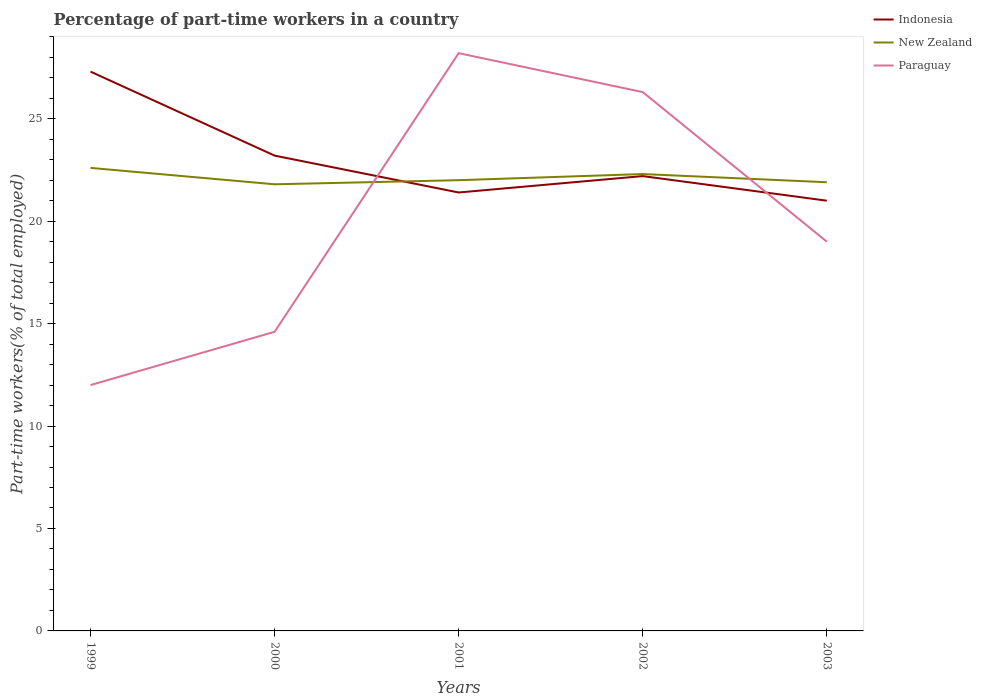How many different coloured lines are there?
Your response must be concise. 3. Does the line corresponding to Indonesia intersect with the line corresponding to New Zealand?
Your answer should be very brief. Yes. Is the number of lines equal to the number of legend labels?
Offer a terse response. Yes. In which year was the percentage of part-time workers in New Zealand maximum?
Your response must be concise. 2000. What is the difference between the highest and the second highest percentage of part-time workers in Indonesia?
Keep it short and to the point. 6.3. Is the percentage of part-time workers in Indonesia strictly greater than the percentage of part-time workers in Paraguay over the years?
Provide a succinct answer. No. Are the values on the major ticks of Y-axis written in scientific E-notation?
Offer a terse response. No. Does the graph contain any zero values?
Keep it short and to the point. No. Where does the legend appear in the graph?
Keep it short and to the point. Top right. How many legend labels are there?
Your response must be concise. 3. What is the title of the graph?
Your answer should be very brief. Percentage of part-time workers in a country. What is the label or title of the X-axis?
Offer a terse response. Years. What is the label or title of the Y-axis?
Ensure brevity in your answer.  Part-time workers(% of total employed). What is the Part-time workers(% of total employed) in Indonesia in 1999?
Offer a terse response. 27.3. What is the Part-time workers(% of total employed) of New Zealand in 1999?
Your answer should be very brief. 22.6. What is the Part-time workers(% of total employed) in Paraguay in 1999?
Keep it short and to the point. 12. What is the Part-time workers(% of total employed) of Indonesia in 2000?
Your answer should be very brief. 23.2. What is the Part-time workers(% of total employed) of New Zealand in 2000?
Offer a very short reply. 21.8. What is the Part-time workers(% of total employed) in Paraguay in 2000?
Your response must be concise. 14.6. What is the Part-time workers(% of total employed) in Indonesia in 2001?
Provide a succinct answer. 21.4. What is the Part-time workers(% of total employed) of New Zealand in 2001?
Your answer should be compact. 22. What is the Part-time workers(% of total employed) in Paraguay in 2001?
Offer a very short reply. 28.2. What is the Part-time workers(% of total employed) of Indonesia in 2002?
Provide a short and direct response. 22.2. What is the Part-time workers(% of total employed) of New Zealand in 2002?
Give a very brief answer. 22.3. What is the Part-time workers(% of total employed) in Paraguay in 2002?
Provide a succinct answer. 26.3. What is the Part-time workers(% of total employed) of Indonesia in 2003?
Offer a very short reply. 21. What is the Part-time workers(% of total employed) in New Zealand in 2003?
Your answer should be very brief. 21.9. Across all years, what is the maximum Part-time workers(% of total employed) of Indonesia?
Offer a very short reply. 27.3. Across all years, what is the maximum Part-time workers(% of total employed) of New Zealand?
Provide a succinct answer. 22.6. Across all years, what is the maximum Part-time workers(% of total employed) in Paraguay?
Your answer should be very brief. 28.2. Across all years, what is the minimum Part-time workers(% of total employed) of New Zealand?
Offer a very short reply. 21.8. What is the total Part-time workers(% of total employed) in Indonesia in the graph?
Keep it short and to the point. 115.1. What is the total Part-time workers(% of total employed) in New Zealand in the graph?
Offer a terse response. 110.6. What is the total Part-time workers(% of total employed) of Paraguay in the graph?
Your response must be concise. 100.1. What is the difference between the Part-time workers(% of total employed) of New Zealand in 1999 and that in 2000?
Keep it short and to the point. 0.8. What is the difference between the Part-time workers(% of total employed) of Indonesia in 1999 and that in 2001?
Your answer should be very brief. 5.9. What is the difference between the Part-time workers(% of total employed) in Paraguay in 1999 and that in 2001?
Ensure brevity in your answer.  -16.2. What is the difference between the Part-time workers(% of total employed) in Indonesia in 1999 and that in 2002?
Ensure brevity in your answer.  5.1. What is the difference between the Part-time workers(% of total employed) in Paraguay in 1999 and that in 2002?
Your response must be concise. -14.3. What is the difference between the Part-time workers(% of total employed) of New Zealand in 1999 and that in 2003?
Make the answer very short. 0.7. What is the difference between the Part-time workers(% of total employed) of Paraguay in 1999 and that in 2003?
Make the answer very short. -7. What is the difference between the Part-time workers(% of total employed) of Indonesia in 2000 and that in 2001?
Ensure brevity in your answer.  1.8. What is the difference between the Part-time workers(% of total employed) in New Zealand in 2000 and that in 2002?
Your answer should be compact. -0.5. What is the difference between the Part-time workers(% of total employed) in Paraguay in 2000 and that in 2002?
Provide a short and direct response. -11.7. What is the difference between the Part-time workers(% of total employed) in Paraguay in 2000 and that in 2003?
Your answer should be very brief. -4.4. What is the difference between the Part-time workers(% of total employed) in Paraguay in 2001 and that in 2002?
Your answer should be compact. 1.9. What is the difference between the Part-time workers(% of total employed) of New Zealand in 2001 and that in 2003?
Provide a short and direct response. 0.1. What is the difference between the Part-time workers(% of total employed) in Paraguay in 2001 and that in 2003?
Ensure brevity in your answer.  9.2. What is the difference between the Part-time workers(% of total employed) of New Zealand in 2002 and that in 2003?
Your answer should be compact. 0.4. What is the difference between the Part-time workers(% of total employed) of Paraguay in 2002 and that in 2003?
Keep it short and to the point. 7.3. What is the difference between the Part-time workers(% of total employed) of Indonesia in 1999 and the Part-time workers(% of total employed) of New Zealand in 2000?
Give a very brief answer. 5.5. What is the difference between the Part-time workers(% of total employed) in Indonesia in 1999 and the Part-time workers(% of total employed) in Paraguay in 2000?
Make the answer very short. 12.7. What is the difference between the Part-time workers(% of total employed) of New Zealand in 1999 and the Part-time workers(% of total employed) of Paraguay in 2002?
Provide a succinct answer. -3.7. What is the difference between the Part-time workers(% of total employed) in Indonesia in 1999 and the Part-time workers(% of total employed) in New Zealand in 2003?
Your answer should be compact. 5.4. What is the difference between the Part-time workers(% of total employed) of Indonesia in 2000 and the Part-time workers(% of total employed) of Paraguay in 2001?
Provide a succinct answer. -5. What is the difference between the Part-time workers(% of total employed) of New Zealand in 2000 and the Part-time workers(% of total employed) of Paraguay in 2001?
Your answer should be very brief. -6.4. What is the difference between the Part-time workers(% of total employed) of Indonesia in 2000 and the Part-time workers(% of total employed) of Paraguay in 2002?
Provide a short and direct response. -3.1. What is the difference between the Part-time workers(% of total employed) in New Zealand in 2000 and the Part-time workers(% of total employed) in Paraguay in 2002?
Offer a terse response. -4.5. What is the difference between the Part-time workers(% of total employed) of Indonesia in 2001 and the Part-time workers(% of total employed) of New Zealand in 2002?
Offer a very short reply. -0.9. What is the difference between the Part-time workers(% of total employed) in Indonesia in 2001 and the Part-time workers(% of total employed) in Paraguay in 2002?
Your answer should be very brief. -4.9. What is the difference between the Part-time workers(% of total employed) of New Zealand in 2001 and the Part-time workers(% of total employed) of Paraguay in 2003?
Keep it short and to the point. 3. What is the difference between the Part-time workers(% of total employed) of Indonesia in 2002 and the Part-time workers(% of total employed) of New Zealand in 2003?
Give a very brief answer. 0.3. What is the difference between the Part-time workers(% of total employed) of Indonesia in 2002 and the Part-time workers(% of total employed) of Paraguay in 2003?
Ensure brevity in your answer.  3.2. What is the difference between the Part-time workers(% of total employed) of New Zealand in 2002 and the Part-time workers(% of total employed) of Paraguay in 2003?
Your answer should be compact. 3.3. What is the average Part-time workers(% of total employed) in Indonesia per year?
Offer a terse response. 23.02. What is the average Part-time workers(% of total employed) of New Zealand per year?
Offer a very short reply. 22.12. What is the average Part-time workers(% of total employed) of Paraguay per year?
Your answer should be compact. 20.02. In the year 2000, what is the difference between the Part-time workers(% of total employed) of Indonesia and Part-time workers(% of total employed) of New Zealand?
Provide a succinct answer. 1.4. In the year 2001, what is the difference between the Part-time workers(% of total employed) of Indonesia and Part-time workers(% of total employed) of New Zealand?
Offer a very short reply. -0.6. In the year 2001, what is the difference between the Part-time workers(% of total employed) of Indonesia and Part-time workers(% of total employed) of Paraguay?
Keep it short and to the point. -6.8. In the year 2002, what is the difference between the Part-time workers(% of total employed) of New Zealand and Part-time workers(% of total employed) of Paraguay?
Provide a short and direct response. -4. In the year 2003, what is the difference between the Part-time workers(% of total employed) in Indonesia and Part-time workers(% of total employed) in New Zealand?
Provide a succinct answer. -0.9. In the year 2003, what is the difference between the Part-time workers(% of total employed) in Indonesia and Part-time workers(% of total employed) in Paraguay?
Ensure brevity in your answer.  2. In the year 2003, what is the difference between the Part-time workers(% of total employed) of New Zealand and Part-time workers(% of total employed) of Paraguay?
Your answer should be very brief. 2.9. What is the ratio of the Part-time workers(% of total employed) of Indonesia in 1999 to that in 2000?
Offer a very short reply. 1.18. What is the ratio of the Part-time workers(% of total employed) of New Zealand in 1999 to that in 2000?
Your response must be concise. 1.04. What is the ratio of the Part-time workers(% of total employed) of Paraguay in 1999 to that in 2000?
Your response must be concise. 0.82. What is the ratio of the Part-time workers(% of total employed) in Indonesia in 1999 to that in 2001?
Provide a short and direct response. 1.28. What is the ratio of the Part-time workers(% of total employed) in New Zealand in 1999 to that in 2001?
Your response must be concise. 1.03. What is the ratio of the Part-time workers(% of total employed) in Paraguay in 1999 to that in 2001?
Make the answer very short. 0.43. What is the ratio of the Part-time workers(% of total employed) of Indonesia in 1999 to that in 2002?
Provide a succinct answer. 1.23. What is the ratio of the Part-time workers(% of total employed) of New Zealand in 1999 to that in 2002?
Your answer should be compact. 1.01. What is the ratio of the Part-time workers(% of total employed) of Paraguay in 1999 to that in 2002?
Keep it short and to the point. 0.46. What is the ratio of the Part-time workers(% of total employed) in Indonesia in 1999 to that in 2003?
Offer a very short reply. 1.3. What is the ratio of the Part-time workers(% of total employed) of New Zealand in 1999 to that in 2003?
Your answer should be compact. 1.03. What is the ratio of the Part-time workers(% of total employed) in Paraguay in 1999 to that in 2003?
Your answer should be very brief. 0.63. What is the ratio of the Part-time workers(% of total employed) of Indonesia in 2000 to that in 2001?
Ensure brevity in your answer.  1.08. What is the ratio of the Part-time workers(% of total employed) in New Zealand in 2000 to that in 2001?
Provide a succinct answer. 0.99. What is the ratio of the Part-time workers(% of total employed) in Paraguay in 2000 to that in 2001?
Keep it short and to the point. 0.52. What is the ratio of the Part-time workers(% of total employed) in Indonesia in 2000 to that in 2002?
Provide a succinct answer. 1.04. What is the ratio of the Part-time workers(% of total employed) of New Zealand in 2000 to that in 2002?
Give a very brief answer. 0.98. What is the ratio of the Part-time workers(% of total employed) in Paraguay in 2000 to that in 2002?
Your response must be concise. 0.56. What is the ratio of the Part-time workers(% of total employed) in Indonesia in 2000 to that in 2003?
Provide a short and direct response. 1.1. What is the ratio of the Part-time workers(% of total employed) in New Zealand in 2000 to that in 2003?
Your response must be concise. 1. What is the ratio of the Part-time workers(% of total employed) in Paraguay in 2000 to that in 2003?
Offer a terse response. 0.77. What is the ratio of the Part-time workers(% of total employed) in New Zealand in 2001 to that in 2002?
Your response must be concise. 0.99. What is the ratio of the Part-time workers(% of total employed) in Paraguay in 2001 to that in 2002?
Keep it short and to the point. 1.07. What is the ratio of the Part-time workers(% of total employed) of Paraguay in 2001 to that in 2003?
Offer a very short reply. 1.48. What is the ratio of the Part-time workers(% of total employed) in Indonesia in 2002 to that in 2003?
Give a very brief answer. 1.06. What is the ratio of the Part-time workers(% of total employed) in New Zealand in 2002 to that in 2003?
Ensure brevity in your answer.  1.02. What is the ratio of the Part-time workers(% of total employed) of Paraguay in 2002 to that in 2003?
Your answer should be very brief. 1.38. What is the difference between the highest and the second highest Part-time workers(% of total employed) in New Zealand?
Provide a short and direct response. 0.3. What is the difference between the highest and the second highest Part-time workers(% of total employed) of Paraguay?
Your answer should be compact. 1.9. What is the difference between the highest and the lowest Part-time workers(% of total employed) in Indonesia?
Provide a succinct answer. 6.3. 